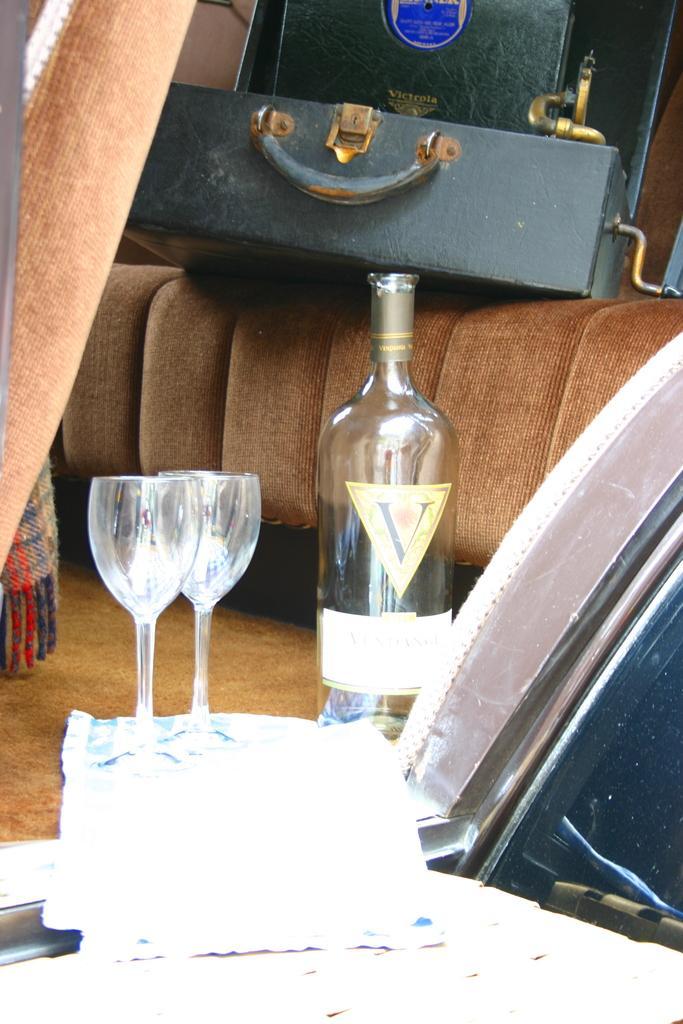In one or two sentences, can you explain what this image depicts? In this picture we can see bottle beside to that two glasses and we have suitcase on sofa and here we can see paper. 